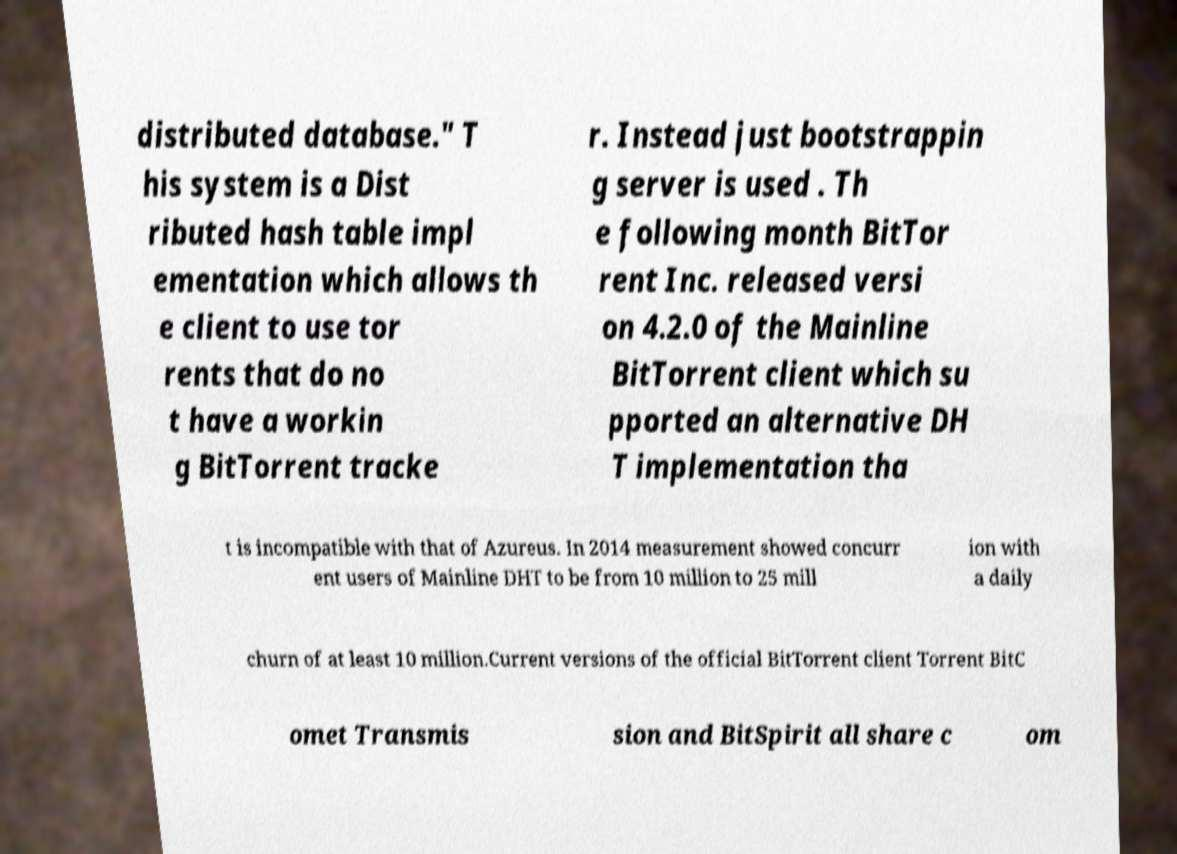Can you accurately transcribe the text from the provided image for me? distributed database." T his system is a Dist ributed hash table impl ementation which allows th e client to use tor rents that do no t have a workin g BitTorrent tracke r. Instead just bootstrappin g server is used . Th e following month BitTor rent Inc. released versi on 4.2.0 of the Mainline BitTorrent client which su pported an alternative DH T implementation tha t is incompatible with that of Azureus. In 2014 measurement showed concurr ent users of Mainline DHT to be from 10 million to 25 mill ion with a daily churn of at least 10 million.Current versions of the official BitTorrent client Torrent BitC omet Transmis sion and BitSpirit all share c om 